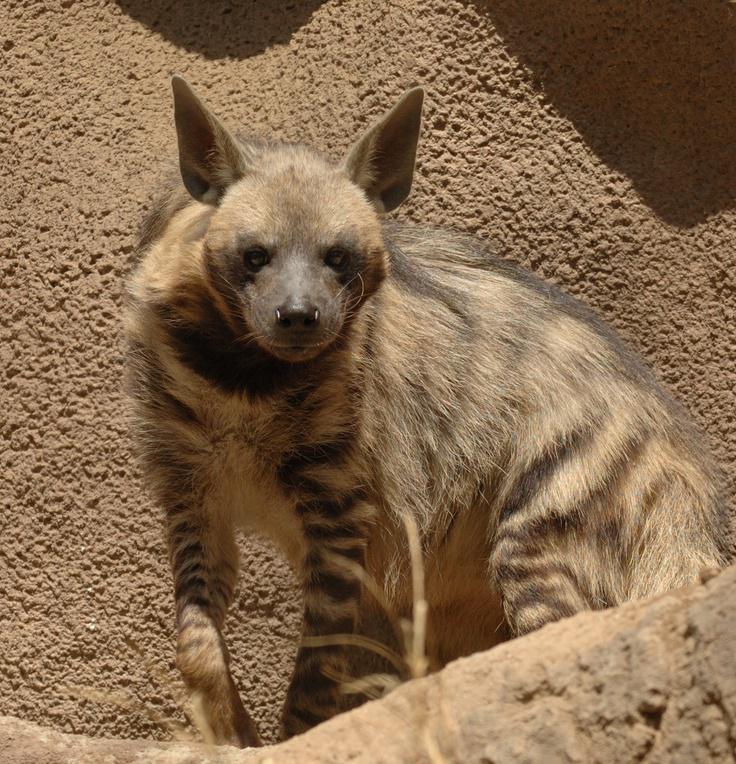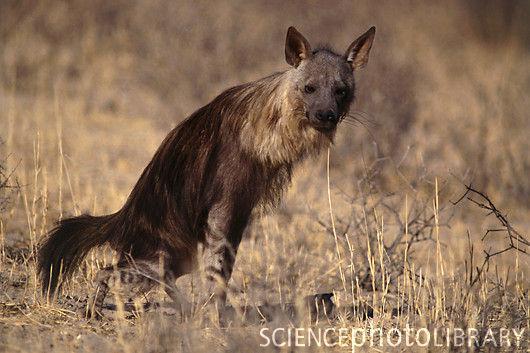The first image is the image on the left, the second image is the image on the right. For the images displayed, is the sentence "There is a hyena standing in water." factually correct? Answer yes or no. No. 